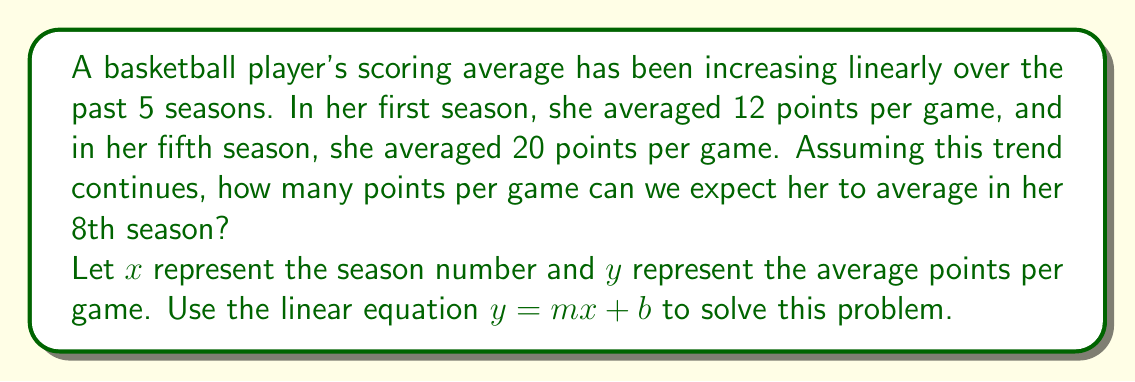Solve this math problem. 1. Identify the two known points:
   $(x_1, y_1) = (1, 12)$ and $(x_2, y_2) = (5, 20)$

2. Calculate the slope (m):
   $m = \frac{y_2 - y_1}{x_2 - x_1} = \frac{20 - 12}{5 - 1} = \frac{8}{4} = 2$

3. Use the point-slope form to find the y-intercept (b):
   $y - y_1 = m(x - x_1)$
   $12 - b = 2(1 - 0)$
   $12 - b = 2$
   $b = 10$

4. Write the linear equation:
   $y = 2x + 10$

5. Predict the average points for the 8th season by substituting $x = 8$:
   $y = 2(8) + 10 = 16 + 10 = 26$
Answer: 26 points per game 